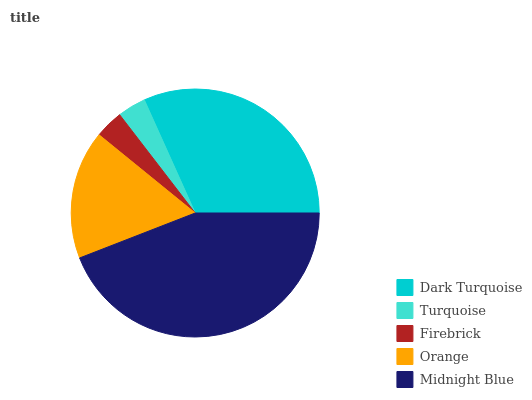Is Firebrick the minimum?
Answer yes or no. Yes. Is Midnight Blue the maximum?
Answer yes or no. Yes. Is Turquoise the minimum?
Answer yes or no. No. Is Turquoise the maximum?
Answer yes or no. No. Is Dark Turquoise greater than Turquoise?
Answer yes or no. Yes. Is Turquoise less than Dark Turquoise?
Answer yes or no. Yes. Is Turquoise greater than Dark Turquoise?
Answer yes or no. No. Is Dark Turquoise less than Turquoise?
Answer yes or no. No. Is Orange the high median?
Answer yes or no. Yes. Is Orange the low median?
Answer yes or no. Yes. Is Midnight Blue the high median?
Answer yes or no. No. Is Turquoise the low median?
Answer yes or no. No. 